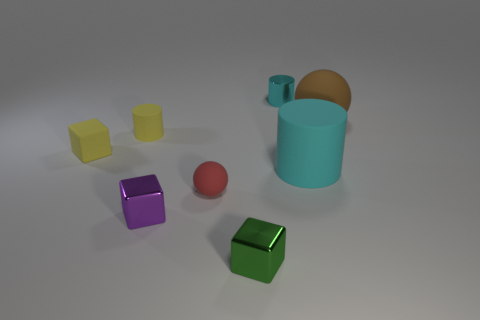The small green thing that is the same material as the purple thing is what shape?
Keep it short and to the point. Cube. Does the tiny yellow cube have the same material as the brown ball?
Your response must be concise. Yes. Are there fewer tiny red matte objects that are on the right side of the cyan shiny cylinder than tiny metallic cylinders on the right side of the brown matte thing?
Offer a terse response. No. The matte cylinder that is the same color as the tiny matte cube is what size?
Offer a very short reply. Small. How many matte balls are right of the cyan cylinder on the right side of the tiny cylinder right of the tiny matte cylinder?
Make the answer very short. 1. Is the small rubber cylinder the same color as the large sphere?
Keep it short and to the point. No. Are there any tiny metal things that have the same color as the large matte sphere?
Ensure brevity in your answer.  No. There is another cylinder that is the same size as the cyan metallic cylinder; what is its color?
Your response must be concise. Yellow. Are there any tiny purple metal objects of the same shape as the cyan shiny thing?
Your answer should be very brief. No. The large matte object that is the same color as the shiny cylinder is what shape?
Offer a very short reply. Cylinder. 